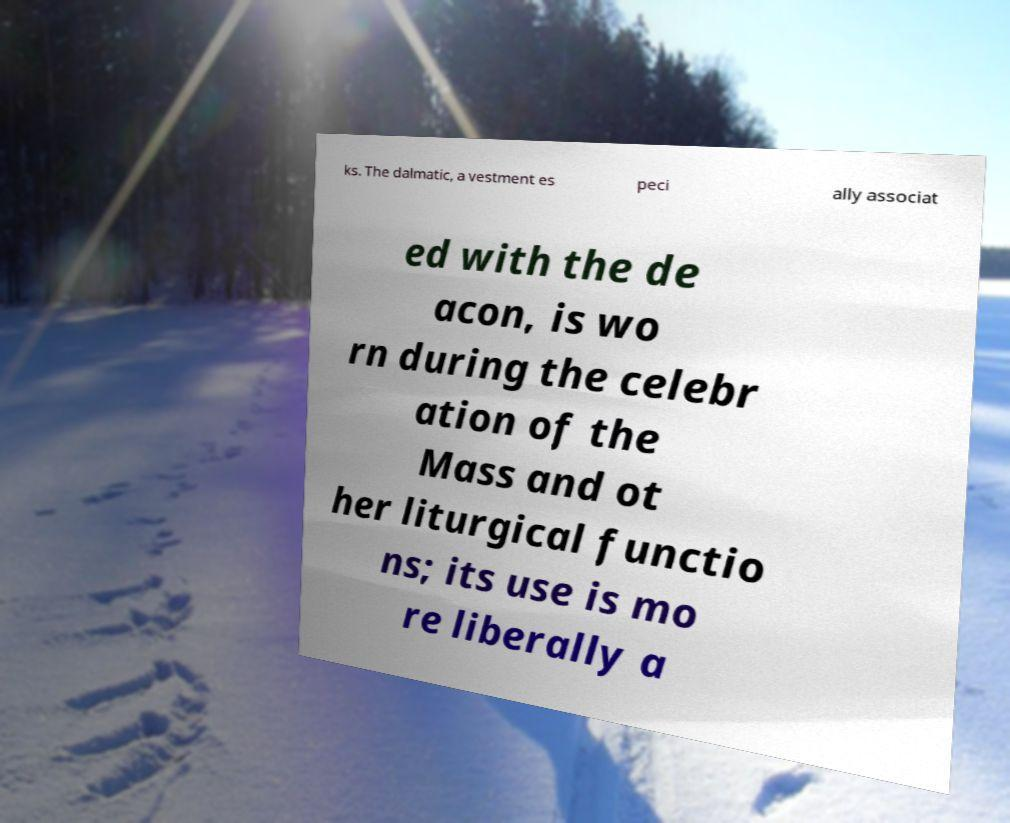Please read and relay the text visible in this image. What does it say? ks. The dalmatic, a vestment es peci ally associat ed with the de acon, is wo rn during the celebr ation of the Mass and ot her liturgical functio ns; its use is mo re liberally a 